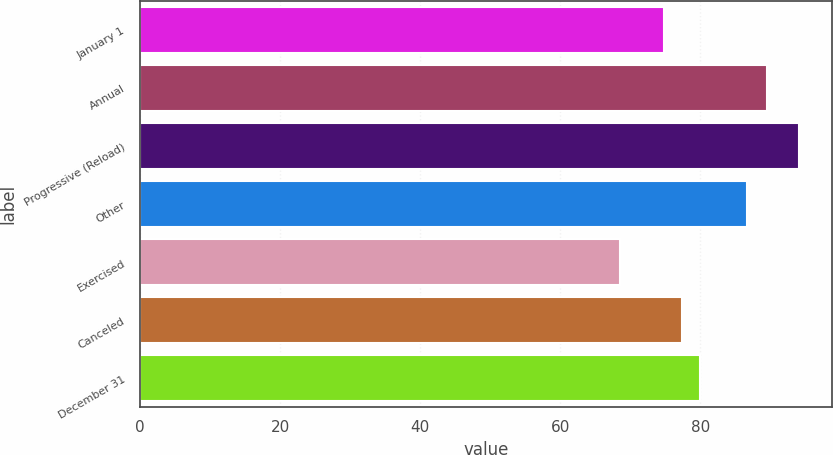Convert chart to OTSL. <chart><loc_0><loc_0><loc_500><loc_500><bar_chart><fcel>January 1<fcel>Annual<fcel>Progressive (Reload)<fcel>Other<fcel>Exercised<fcel>Canceled<fcel>December 31<nl><fcel>74.8<fcel>89.46<fcel>94.02<fcel>86.71<fcel>68.47<fcel>77.35<fcel>79.91<nl></chart> 